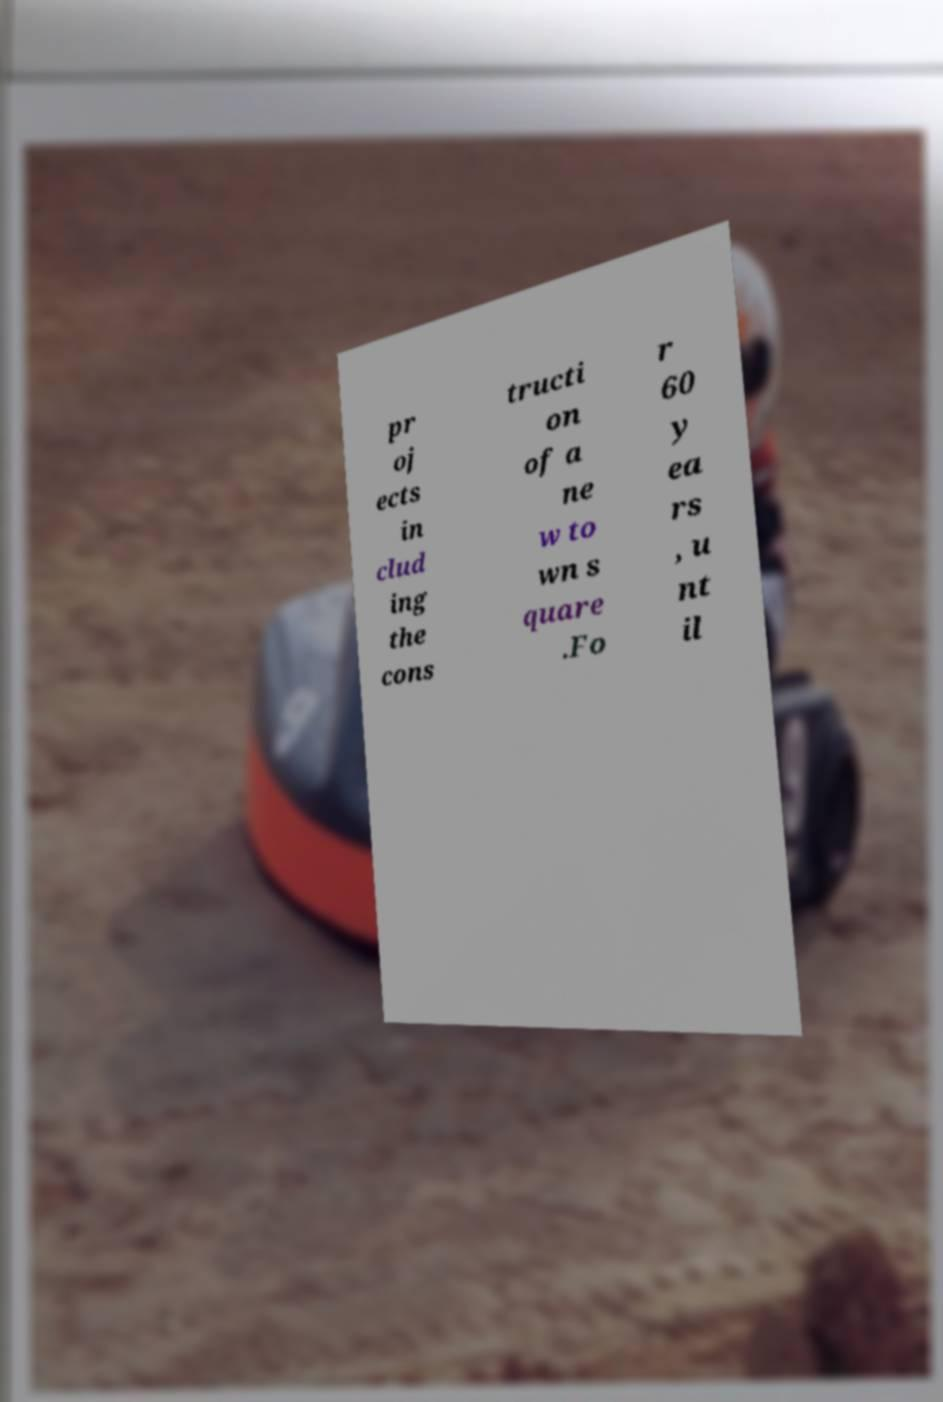I need the written content from this picture converted into text. Can you do that? pr oj ects in clud ing the cons tructi on of a ne w to wn s quare .Fo r 60 y ea rs , u nt il 